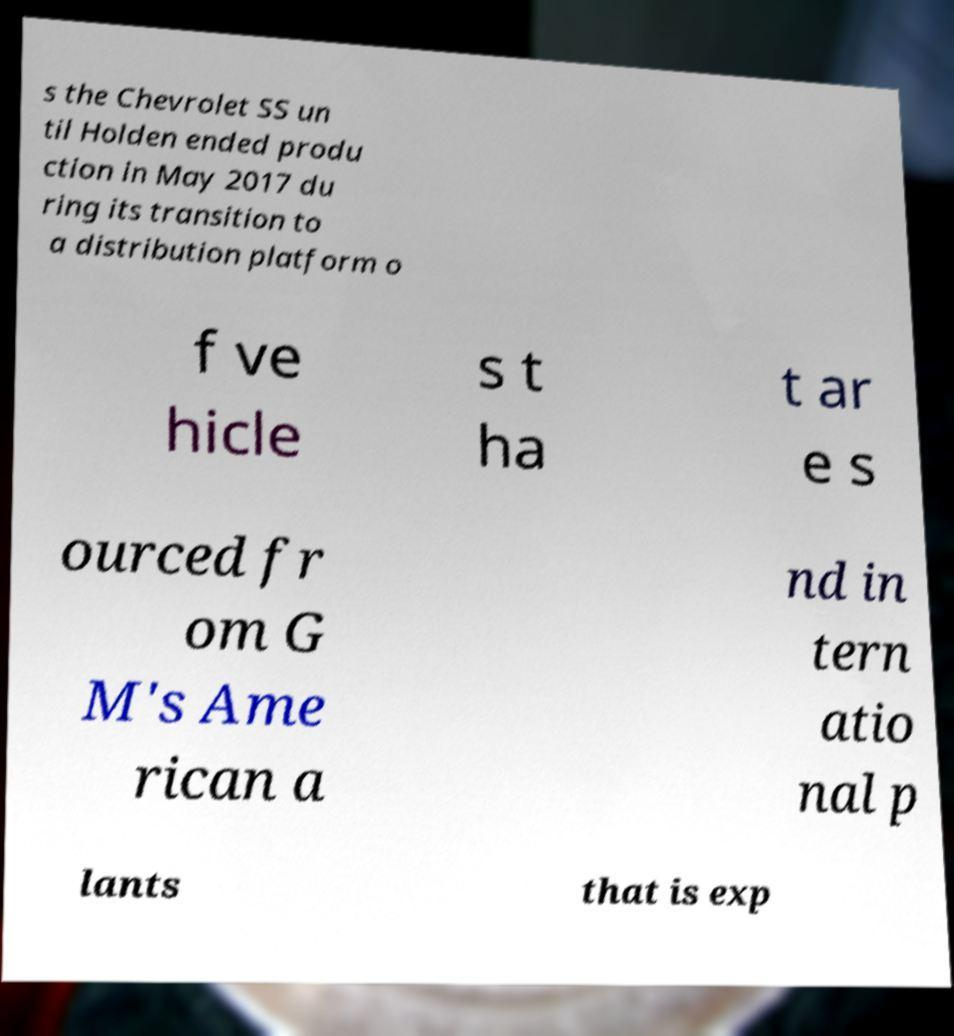Can you accurately transcribe the text from the provided image for me? s the Chevrolet SS un til Holden ended produ ction in May 2017 du ring its transition to a distribution platform o f ve hicle s t ha t ar e s ourced fr om G M's Ame rican a nd in tern atio nal p lants that is exp 